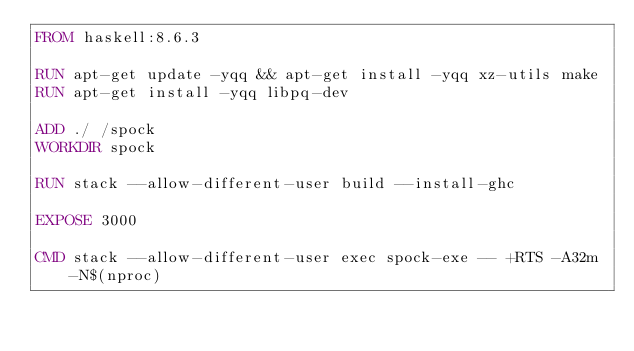<code> <loc_0><loc_0><loc_500><loc_500><_Dockerfile_>FROM haskell:8.6.3

RUN apt-get update -yqq && apt-get install -yqq xz-utils make
RUN apt-get install -yqq libpq-dev

ADD ./ /spock
WORKDIR spock

RUN stack --allow-different-user build --install-ghc

EXPOSE 3000

CMD stack --allow-different-user exec spock-exe -- +RTS -A32m -N$(nproc)
</code> 